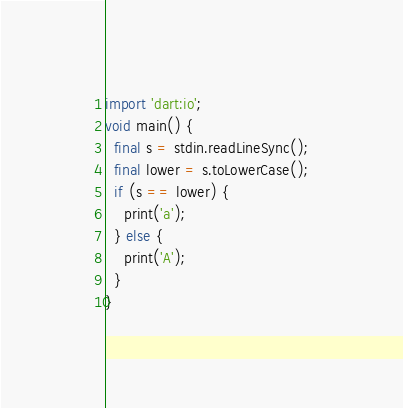Convert code to text. <code><loc_0><loc_0><loc_500><loc_500><_Dart_>import 'dart:io';
void main() {
  final s = stdin.readLineSync();
  final lower = s.toLowerCase();
  if (s == lower) {
    print('a');
  } else {
    print('A');
  }
}</code> 